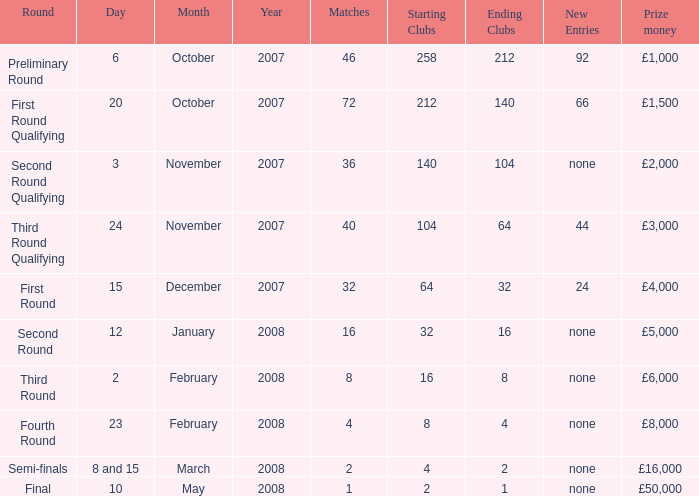How many new entries this round are there with more than 16 matches and a third round qualifying? 44.0. 